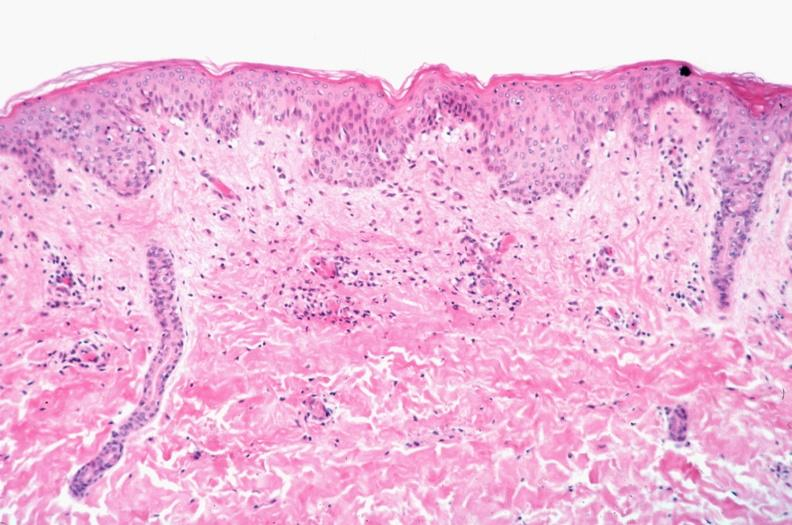what is rocky mountain spotted?
Answer the question using a single word or phrase. Fever 